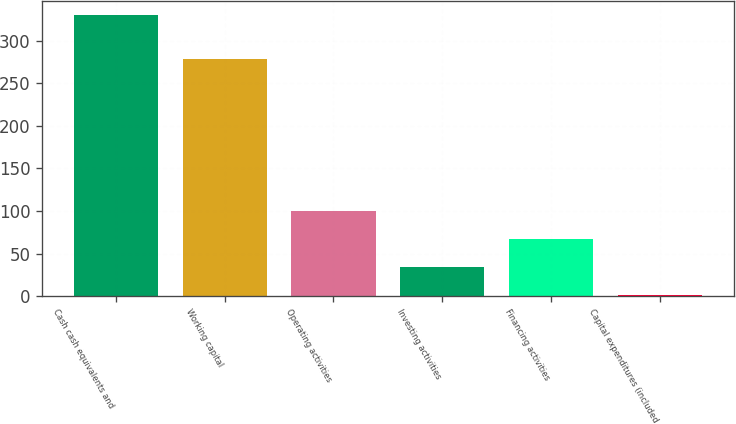Convert chart to OTSL. <chart><loc_0><loc_0><loc_500><loc_500><bar_chart><fcel>Cash cash equivalents and<fcel>Working capital<fcel>Operating activities<fcel>Investing activities<fcel>Financing activities<fcel>Capital expenditures (included<nl><fcel>329.8<fcel>278.4<fcel>100.06<fcel>34.42<fcel>67.24<fcel>1.6<nl></chart> 